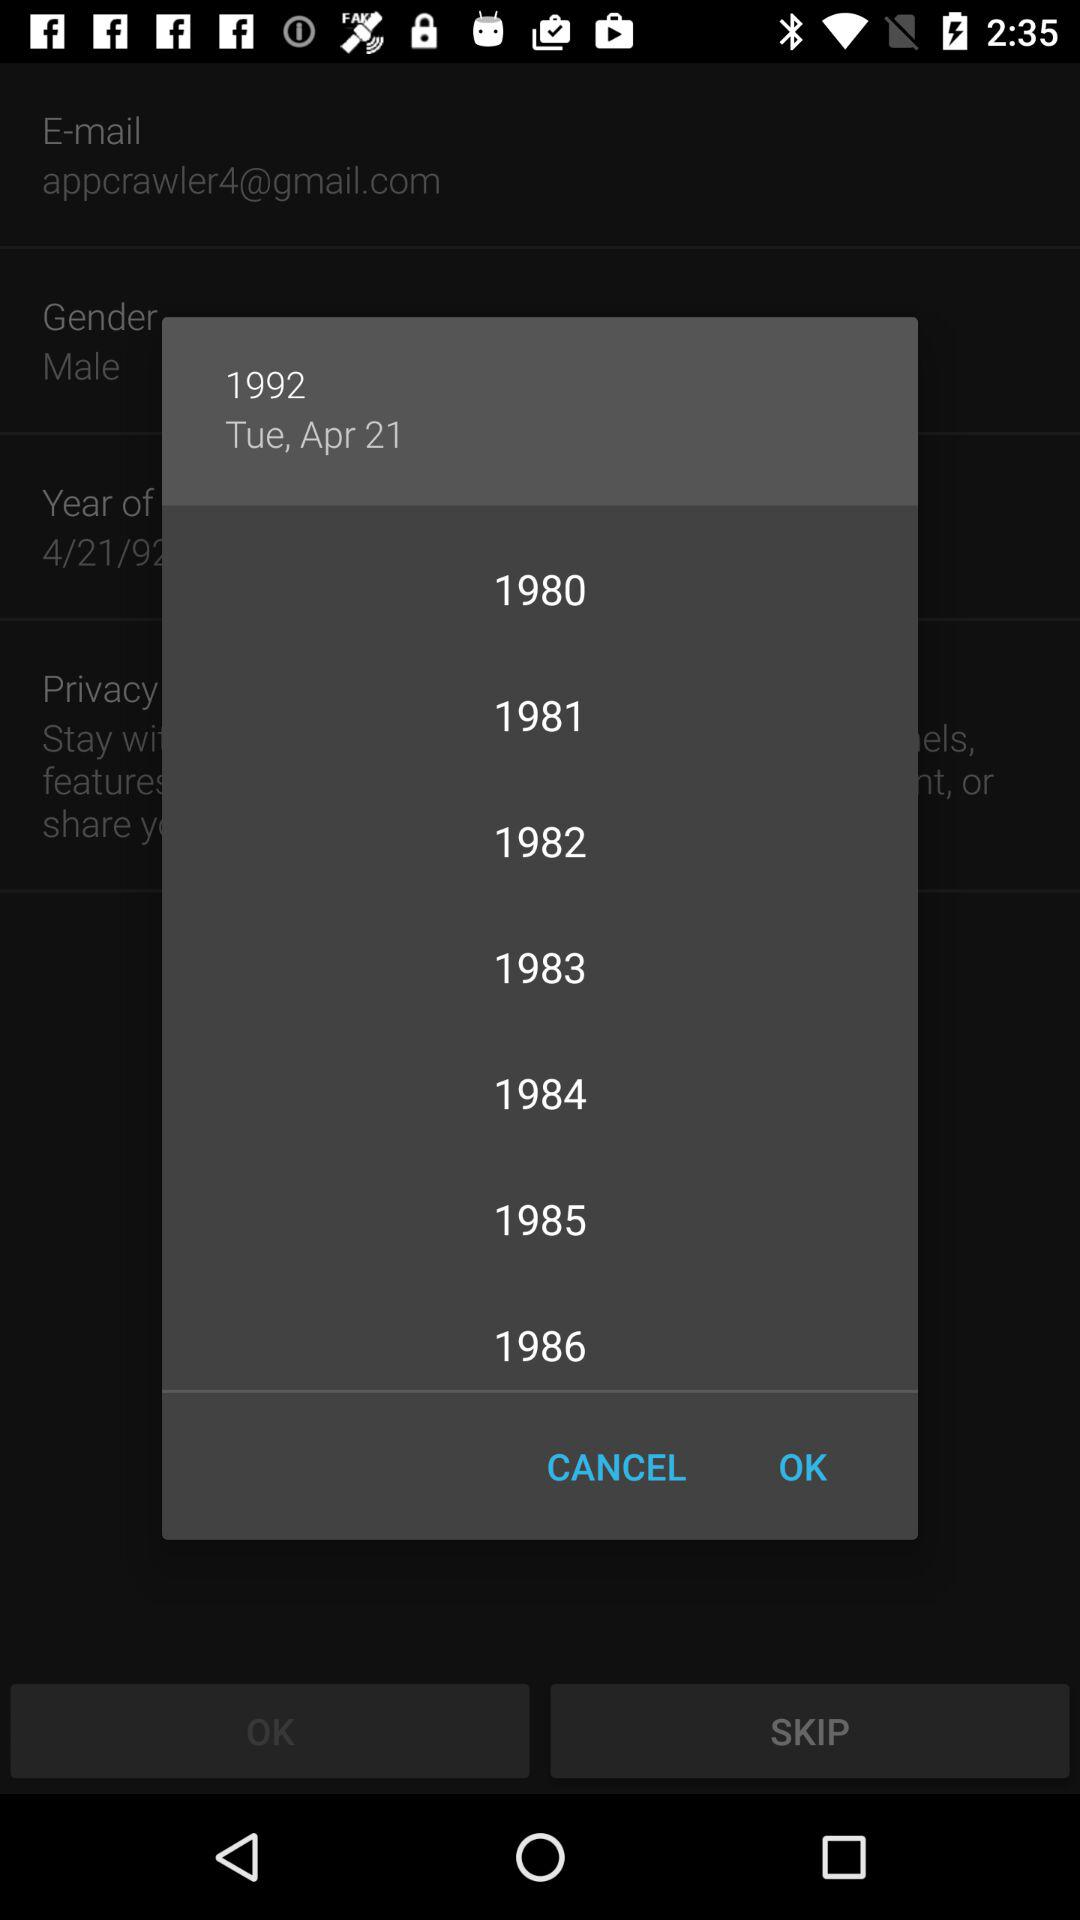What are the available years in the list? The available years in the list are 1980, 1981, 1982, 1983, 1984, 1985 and 1986. 